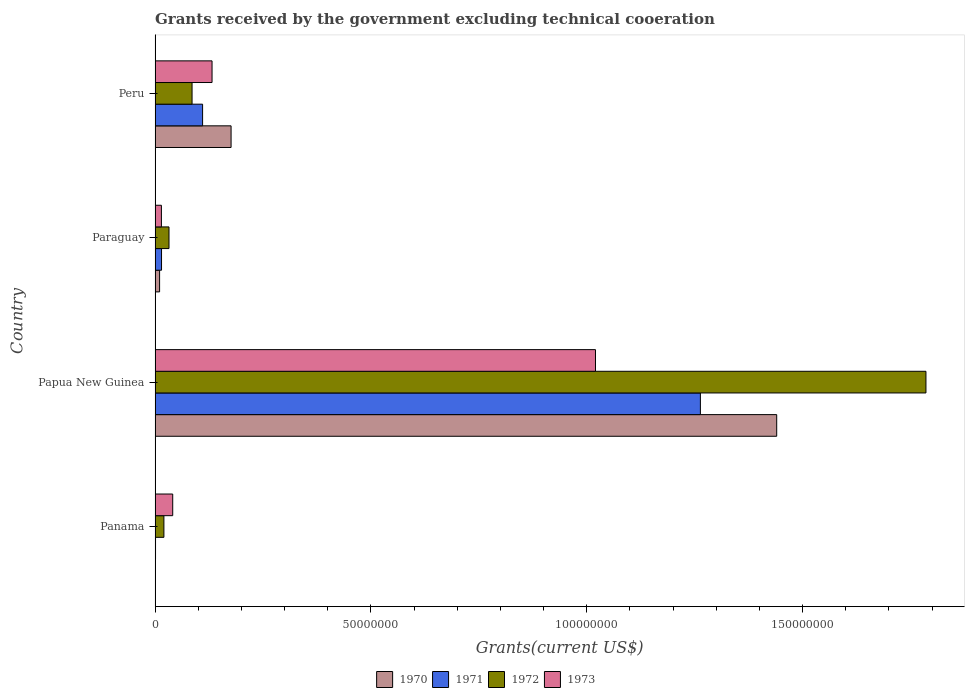How many different coloured bars are there?
Your answer should be compact. 4. How many groups of bars are there?
Ensure brevity in your answer.  4. Are the number of bars per tick equal to the number of legend labels?
Ensure brevity in your answer.  No. Are the number of bars on each tick of the Y-axis equal?
Provide a short and direct response. No. How many bars are there on the 2nd tick from the bottom?
Keep it short and to the point. 4. What is the label of the 4th group of bars from the top?
Ensure brevity in your answer.  Panama. What is the total grants received by the government in 1971 in Panama?
Your answer should be very brief. 1.10e+05. Across all countries, what is the maximum total grants received by the government in 1970?
Give a very brief answer. 1.44e+08. Across all countries, what is the minimum total grants received by the government in 1972?
Offer a terse response. 2.05e+06. In which country was the total grants received by the government in 1973 maximum?
Offer a very short reply. Papua New Guinea. What is the total total grants received by the government in 1973 in the graph?
Your answer should be very brief. 1.21e+08. What is the difference between the total grants received by the government in 1971 in Panama and that in Papua New Guinea?
Offer a very short reply. -1.26e+08. What is the difference between the total grants received by the government in 1973 in Papua New Guinea and the total grants received by the government in 1972 in Paraguay?
Make the answer very short. 9.88e+07. What is the average total grants received by the government in 1970 per country?
Your answer should be compact. 4.07e+07. What is the difference between the total grants received by the government in 1972 and total grants received by the government in 1970 in Papua New Guinea?
Provide a succinct answer. 3.46e+07. What is the ratio of the total grants received by the government in 1972 in Panama to that in Peru?
Your response must be concise. 0.24. Is the difference between the total grants received by the government in 1972 in Papua New Guinea and Peru greater than the difference between the total grants received by the government in 1970 in Papua New Guinea and Peru?
Offer a very short reply. Yes. What is the difference between the highest and the second highest total grants received by the government in 1970?
Your response must be concise. 1.26e+08. What is the difference between the highest and the lowest total grants received by the government in 1971?
Your answer should be compact. 1.26e+08. Is the sum of the total grants received by the government in 1972 in Panama and Papua New Guinea greater than the maximum total grants received by the government in 1971 across all countries?
Provide a succinct answer. Yes. Is it the case that in every country, the sum of the total grants received by the government in 1973 and total grants received by the government in 1970 is greater than the sum of total grants received by the government in 1972 and total grants received by the government in 1971?
Offer a terse response. No. Is it the case that in every country, the sum of the total grants received by the government in 1970 and total grants received by the government in 1973 is greater than the total grants received by the government in 1972?
Give a very brief answer. No. How many bars are there?
Your answer should be very brief. 15. Are all the bars in the graph horizontal?
Ensure brevity in your answer.  Yes. How many countries are there in the graph?
Provide a short and direct response. 4. Does the graph contain grids?
Provide a succinct answer. No. How are the legend labels stacked?
Ensure brevity in your answer.  Horizontal. What is the title of the graph?
Provide a succinct answer. Grants received by the government excluding technical cooeration. What is the label or title of the X-axis?
Make the answer very short. Grants(current US$). What is the Grants(current US$) of 1971 in Panama?
Your answer should be very brief. 1.10e+05. What is the Grants(current US$) of 1972 in Panama?
Offer a terse response. 2.05e+06. What is the Grants(current US$) in 1973 in Panama?
Your answer should be very brief. 4.09e+06. What is the Grants(current US$) of 1970 in Papua New Guinea?
Ensure brevity in your answer.  1.44e+08. What is the Grants(current US$) of 1971 in Papua New Guinea?
Your answer should be very brief. 1.26e+08. What is the Grants(current US$) of 1972 in Papua New Guinea?
Offer a terse response. 1.79e+08. What is the Grants(current US$) of 1973 in Papua New Guinea?
Keep it short and to the point. 1.02e+08. What is the Grants(current US$) in 1970 in Paraguay?
Offer a very short reply. 1.05e+06. What is the Grants(current US$) of 1971 in Paraguay?
Your answer should be compact. 1.50e+06. What is the Grants(current US$) of 1972 in Paraguay?
Offer a terse response. 3.23e+06. What is the Grants(current US$) of 1973 in Paraguay?
Provide a short and direct response. 1.47e+06. What is the Grants(current US$) in 1970 in Peru?
Provide a succinct answer. 1.76e+07. What is the Grants(current US$) in 1971 in Peru?
Provide a short and direct response. 1.10e+07. What is the Grants(current US$) in 1972 in Peru?
Your answer should be very brief. 8.57e+06. What is the Grants(current US$) in 1973 in Peru?
Provide a short and direct response. 1.32e+07. Across all countries, what is the maximum Grants(current US$) in 1970?
Your response must be concise. 1.44e+08. Across all countries, what is the maximum Grants(current US$) of 1971?
Your answer should be compact. 1.26e+08. Across all countries, what is the maximum Grants(current US$) in 1972?
Make the answer very short. 1.79e+08. Across all countries, what is the maximum Grants(current US$) in 1973?
Provide a short and direct response. 1.02e+08. Across all countries, what is the minimum Grants(current US$) of 1971?
Provide a short and direct response. 1.10e+05. Across all countries, what is the minimum Grants(current US$) in 1972?
Your answer should be very brief. 2.05e+06. Across all countries, what is the minimum Grants(current US$) of 1973?
Your response must be concise. 1.47e+06. What is the total Grants(current US$) of 1970 in the graph?
Give a very brief answer. 1.63e+08. What is the total Grants(current US$) of 1971 in the graph?
Your answer should be compact. 1.39e+08. What is the total Grants(current US$) of 1972 in the graph?
Your answer should be compact. 1.92e+08. What is the total Grants(current US$) in 1973 in the graph?
Provide a short and direct response. 1.21e+08. What is the difference between the Grants(current US$) of 1971 in Panama and that in Papua New Guinea?
Provide a short and direct response. -1.26e+08. What is the difference between the Grants(current US$) in 1972 in Panama and that in Papua New Guinea?
Offer a terse response. -1.77e+08. What is the difference between the Grants(current US$) in 1973 in Panama and that in Papua New Guinea?
Provide a short and direct response. -9.79e+07. What is the difference between the Grants(current US$) of 1971 in Panama and that in Paraguay?
Your answer should be compact. -1.39e+06. What is the difference between the Grants(current US$) in 1972 in Panama and that in Paraguay?
Offer a very short reply. -1.18e+06. What is the difference between the Grants(current US$) in 1973 in Panama and that in Paraguay?
Your response must be concise. 2.62e+06. What is the difference between the Grants(current US$) in 1971 in Panama and that in Peru?
Offer a very short reply. -1.09e+07. What is the difference between the Grants(current US$) of 1972 in Panama and that in Peru?
Your answer should be very brief. -6.52e+06. What is the difference between the Grants(current US$) of 1973 in Panama and that in Peru?
Make the answer very short. -9.11e+06. What is the difference between the Grants(current US$) of 1970 in Papua New Guinea and that in Paraguay?
Provide a succinct answer. 1.43e+08. What is the difference between the Grants(current US$) in 1971 in Papua New Guinea and that in Paraguay?
Provide a succinct answer. 1.25e+08. What is the difference between the Grants(current US$) in 1972 in Papua New Guinea and that in Paraguay?
Keep it short and to the point. 1.75e+08. What is the difference between the Grants(current US$) in 1973 in Papua New Guinea and that in Paraguay?
Provide a short and direct response. 1.01e+08. What is the difference between the Grants(current US$) in 1970 in Papua New Guinea and that in Peru?
Make the answer very short. 1.26e+08. What is the difference between the Grants(current US$) in 1971 in Papua New Guinea and that in Peru?
Your answer should be very brief. 1.15e+08. What is the difference between the Grants(current US$) of 1972 in Papua New Guinea and that in Peru?
Offer a terse response. 1.70e+08. What is the difference between the Grants(current US$) in 1973 in Papua New Guinea and that in Peru?
Your answer should be very brief. 8.88e+07. What is the difference between the Grants(current US$) in 1970 in Paraguay and that in Peru?
Ensure brevity in your answer.  -1.66e+07. What is the difference between the Grants(current US$) in 1971 in Paraguay and that in Peru?
Your answer should be compact. -9.51e+06. What is the difference between the Grants(current US$) in 1972 in Paraguay and that in Peru?
Provide a short and direct response. -5.34e+06. What is the difference between the Grants(current US$) in 1973 in Paraguay and that in Peru?
Your response must be concise. -1.17e+07. What is the difference between the Grants(current US$) of 1971 in Panama and the Grants(current US$) of 1972 in Papua New Guinea?
Make the answer very short. -1.78e+08. What is the difference between the Grants(current US$) of 1971 in Panama and the Grants(current US$) of 1973 in Papua New Guinea?
Offer a very short reply. -1.02e+08. What is the difference between the Grants(current US$) of 1972 in Panama and the Grants(current US$) of 1973 in Papua New Guinea?
Give a very brief answer. -1.00e+08. What is the difference between the Grants(current US$) of 1971 in Panama and the Grants(current US$) of 1972 in Paraguay?
Your response must be concise. -3.12e+06. What is the difference between the Grants(current US$) of 1971 in Panama and the Grants(current US$) of 1973 in Paraguay?
Offer a very short reply. -1.36e+06. What is the difference between the Grants(current US$) in 1972 in Panama and the Grants(current US$) in 1973 in Paraguay?
Ensure brevity in your answer.  5.80e+05. What is the difference between the Grants(current US$) in 1971 in Panama and the Grants(current US$) in 1972 in Peru?
Give a very brief answer. -8.46e+06. What is the difference between the Grants(current US$) in 1971 in Panama and the Grants(current US$) in 1973 in Peru?
Keep it short and to the point. -1.31e+07. What is the difference between the Grants(current US$) of 1972 in Panama and the Grants(current US$) of 1973 in Peru?
Provide a short and direct response. -1.12e+07. What is the difference between the Grants(current US$) in 1970 in Papua New Guinea and the Grants(current US$) in 1971 in Paraguay?
Offer a very short reply. 1.42e+08. What is the difference between the Grants(current US$) in 1970 in Papua New Guinea and the Grants(current US$) in 1972 in Paraguay?
Ensure brevity in your answer.  1.41e+08. What is the difference between the Grants(current US$) in 1970 in Papua New Guinea and the Grants(current US$) in 1973 in Paraguay?
Your response must be concise. 1.43e+08. What is the difference between the Grants(current US$) in 1971 in Papua New Guinea and the Grants(current US$) in 1972 in Paraguay?
Your response must be concise. 1.23e+08. What is the difference between the Grants(current US$) of 1971 in Papua New Guinea and the Grants(current US$) of 1973 in Paraguay?
Keep it short and to the point. 1.25e+08. What is the difference between the Grants(current US$) of 1972 in Papua New Guinea and the Grants(current US$) of 1973 in Paraguay?
Provide a short and direct response. 1.77e+08. What is the difference between the Grants(current US$) of 1970 in Papua New Guinea and the Grants(current US$) of 1971 in Peru?
Make the answer very short. 1.33e+08. What is the difference between the Grants(current US$) of 1970 in Papua New Guinea and the Grants(current US$) of 1972 in Peru?
Your answer should be compact. 1.35e+08. What is the difference between the Grants(current US$) in 1970 in Papua New Guinea and the Grants(current US$) in 1973 in Peru?
Your response must be concise. 1.31e+08. What is the difference between the Grants(current US$) in 1971 in Papua New Guinea and the Grants(current US$) in 1972 in Peru?
Your answer should be very brief. 1.18e+08. What is the difference between the Grants(current US$) in 1971 in Papua New Guinea and the Grants(current US$) in 1973 in Peru?
Ensure brevity in your answer.  1.13e+08. What is the difference between the Grants(current US$) in 1972 in Papua New Guinea and the Grants(current US$) in 1973 in Peru?
Make the answer very short. 1.65e+08. What is the difference between the Grants(current US$) in 1970 in Paraguay and the Grants(current US$) in 1971 in Peru?
Your answer should be compact. -9.96e+06. What is the difference between the Grants(current US$) of 1970 in Paraguay and the Grants(current US$) of 1972 in Peru?
Your answer should be compact. -7.52e+06. What is the difference between the Grants(current US$) of 1970 in Paraguay and the Grants(current US$) of 1973 in Peru?
Make the answer very short. -1.22e+07. What is the difference between the Grants(current US$) in 1971 in Paraguay and the Grants(current US$) in 1972 in Peru?
Your answer should be compact. -7.07e+06. What is the difference between the Grants(current US$) in 1971 in Paraguay and the Grants(current US$) in 1973 in Peru?
Make the answer very short. -1.17e+07. What is the difference between the Grants(current US$) in 1972 in Paraguay and the Grants(current US$) in 1973 in Peru?
Provide a succinct answer. -9.97e+06. What is the average Grants(current US$) in 1970 per country?
Ensure brevity in your answer.  4.07e+07. What is the average Grants(current US$) of 1971 per country?
Give a very brief answer. 3.47e+07. What is the average Grants(current US$) in 1972 per country?
Keep it short and to the point. 4.81e+07. What is the average Grants(current US$) of 1973 per country?
Offer a terse response. 3.02e+07. What is the difference between the Grants(current US$) in 1971 and Grants(current US$) in 1972 in Panama?
Your answer should be very brief. -1.94e+06. What is the difference between the Grants(current US$) of 1971 and Grants(current US$) of 1973 in Panama?
Give a very brief answer. -3.98e+06. What is the difference between the Grants(current US$) of 1972 and Grants(current US$) of 1973 in Panama?
Provide a succinct answer. -2.04e+06. What is the difference between the Grants(current US$) in 1970 and Grants(current US$) in 1971 in Papua New Guinea?
Keep it short and to the point. 1.77e+07. What is the difference between the Grants(current US$) of 1970 and Grants(current US$) of 1972 in Papua New Guinea?
Offer a terse response. -3.46e+07. What is the difference between the Grants(current US$) of 1970 and Grants(current US$) of 1973 in Papua New Guinea?
Make the answer very short. 4.20e+07. What is the difference between the Grants(current US$) of 1971 and Grants(current US$) of 1972 in Papua New Guinea?
Your answer should be very brief. -5.22e+07. What is the difference between the Grants(current US$) of 1971 and Grants(current US$) of 1973 in Papua New Guinea?
Your response must be concise. 2.43e+07. What is the difference between the Grants(current US$) of 1972 and Grants(current US$) of 1973 in Papua New Guinea?
Your answer should be compact. 7.66e+07. What is the difference between the Grants(current US$) in 1970 and Grants(current US$) in 1971 in Paraguay?
Ensure brevity in your answer.  -4.50e+05. What is the difference between the Grants(current US$) of 1970 and Grants(current US$) of 1972 in Paraguay?
Your answer should be very brief. -2.18e+06. What is the difference between the Grants(current US$) of 1970 and Grants(current US$) of 1973 in Paraguay?
Provide a short and direct response. -4.20e+05. What is the difference between the Grants(current US$) of 1971 and Grants(current US$) of 1972 in Paraguay?
Keep it short and to the point. -1.73e+06. What is the difference between the Grants(current US$) in 1972 and Grants(current US$) in 1973 in Paraguay?
Provide a short and direct response. 1.76e+06. What is the difference between the Grants(current US$) in 1970 and Grants(current US$) in 1971 in Peru?
Your answer should be very brief. 6.60e+06. What is the difference between the Grants(current US$) of 1970 and Grants(current US$) of 1972 in Peru?
Your response must be concise. 9.04e+06. What is the difference between the Grants(current US$) of 1970 and Grants(current US$) of 1973 in Peru?
Provide a short and direct response. 4.41e+06. What is the difference between the Grants(current US$) in 1971 and Grants(current US$) in 1972 in Peru?
Make the answer very short. 2.44e+06. What is the difference between the Grants(current US$) in 1971 and Grants(current US$) in 1973 in Peru?
Give a very brief answer. -2.19e+06. What is the difference between the Grants(current US$) of 1972 and Grants(current US$) of 1973 in Peru?
Provide a succinct answer. -4.63e+06. What is the ratio of the Grants(current US$) of 1971 in Panama to that in Papua New Guinea?
Offer a very short reply. 0. What is the ratio of the Grants(current US$) of 1972 in Panama to that in Papua New Guinea?
Ensure brevity in your answer.  0.01. What is the ratio of the Grants(current US$) of 1973 in Panama to that in Papua New Guinea?
Your answer should be very brief. 0.04. What is the ratio of the Grants(current US$) in 1971 in Panama to that in Paraguay?
Your response must be concise. 0.07. What is the ratio of the Grants(current US$) in 1972 in Panama to that in Paraguay?
Offer a terse response. 0.63. What is the ratio of the Grants(current US$) of 1973 in Panama to that in Paraguay?
Make the answer very short. 2.78. What is the ratio of the Grants(current US$) in 1972 in Panama to that in Peru?
Offer a terse response. 0.24. What is the ratio of the Grants(current US$) of 1973 in Panama to that in Peru?
Your response must be concise. 0.31. What is the ratio of the Grants(current US$) of 1970 in Papua New Guinea to that in Paraguay?
Offer a very short reply. 137.14. What is the ratio of the Grants(current US$) in 1971 in Papua New Guinea to that in Paraguay?
Make the answer very short. 84.21. What is the ratio of the Grants(current US$) in 1972 in Papua New Guinea to that in Paraguay?
Your response must be concise. 55.28. What is the ratio of the Grants(current US$) in 1973 in Papua New Guinea to that in Paraguay?
Keep it short and to the point. 69.4. What is the ratio of the Grants(current US$) of 1970 in Papua New Guinea to that in Peru?
Offer a terse response. 8.18. What is the ratio of the Grants(current US$) in 1971 in Papua New Guinea to that in Peru?
Your answer should be very brief. 11.47. What is the ratio of the Grants(current US$) of 1972 in Papua New Guinea to that in Peru?
Offer a very short reply. 20.84. What is the ratio of the Grants(current US$) in 1973 in Papua New Guinea to that in Peru?
Your answer should be compact. 7.73. What is the ratio of the Grants(current US$) in 1970 in Paraguay to that in Peru?
Provide a succinct answer. 0.06. What is the ratio of the Grants(current US$) of 1971 in Paraguay to that in Peru?
Provide a short and direct response. 0.14. What is the ratio of the Grants(current US$) in 1972 in Paraguay to that in Peru?
Your response must be concise. 0.38. What is the ratio of the Grants(current US$) in 1973 in Paraguay to that in Peru?
Ensure brevity in your answer.  0.11. What is the difference between the highest and the second highest Grants(current US$) of 1970?
Provide a short and direct response. 1.26e+08. What is the difference between the highest and the second highest Grants(current US$) in 1971?
Provide a short and direct response. 1.15e+08. What is the difference between the highest and the second highest Grants(current US$) of 1972?
Offer a very short reply. 1.70e+08. What is the difference between the highest and the second highest Grants(current US$) of 1973?
Offer a very short reply. 8.88e+07. What is the difference between the highest and the lowest Grants(current US$) of 1970?
Provide a succinct answer. 1.44e+08. What is the difference between the highest and the lowest Grants(current US$) of 1971?
Your response must be concise. 1.26e+08. What is the difference between the highest and the lowest Grants(current US$) in 1972?
Offer a terse response. 1.77e+08. What is the difference between the highest and the lowest Grants(current US$) of 1973?
Give a very brief answer. 1.01e+08. 